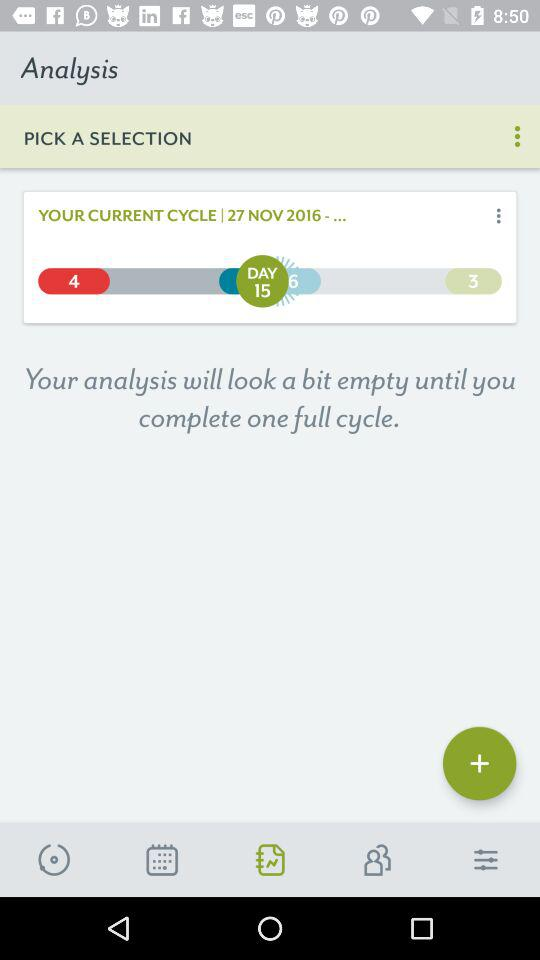How many days are there in the current cycle?
Answer the question using a single word or phrase. 15 